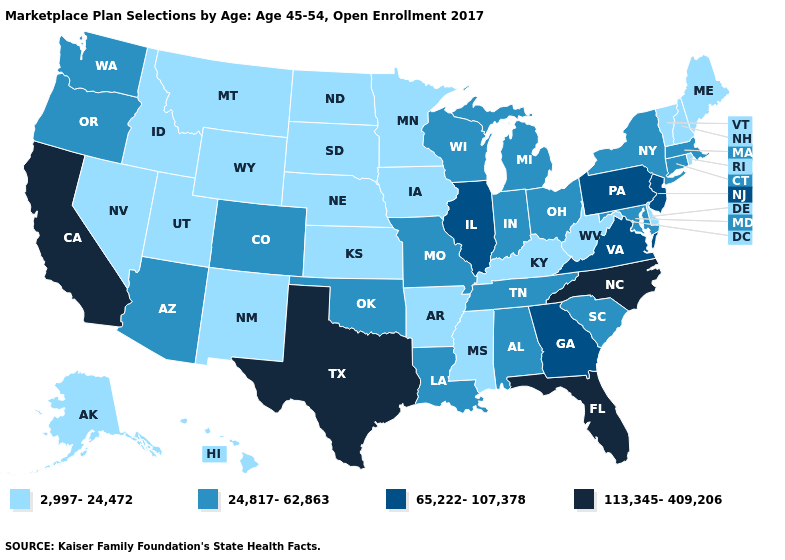Does Pennsylvania have the highest value in the Northeast?
Give a very brief answer. Yes. Does the first symbol in the legend represent the smallest category?
Write a very short answer. Yes. Among the states that border Wisconsin , does Minnesota have the highest value?
Give a very brief answer. No. Name the states that have a value in the range 65,222-107,378?
Be succinct. Georgia, Illinois, New Jersey, Pennsylvania, Virginia. Which states have the highest value in the USA?
Keep it brief. California, Florida, North Carolina, Texas. What is the highest value in states that border South Carolina?
Concise answer only. 113,345-409,206. What is the highest value in states that border Connecticut?
Keep it brief. 24,817-62,863. Name the states that have a value in the range 65,222-107,378?
Quick response, please. Georgia, Illinois, New Jersey, Pennsylvania, Virginia. Among the states that border New Jersey , which have the lowest value?
Concise answer only. Delaware. Among the states that border Florida , does Alabama have the highest value?
Concise answer only. No. Does Connecticut have the lowest value in the Northeast?
Concise answer only. No. What is the highest value in the USA?
Write a very short answer. 113,345-409,206. Does the first symbol in the legend represent the smallest category?
Short answer required. Yes. Name the states that have a value in the range 24,817-62,863?
Be succinct. Alabama, Arizona, Colorado, Connecticut, Indiana, Louisiana, Maryland, Massachusetts, Michigan, Missouri, New York, Ohio, Oklahoma, Oregon, South Carolina, Tennessee, Washington, Wisconsin. How many symbols are there in the legend?
Give a very brief answer. 4. 